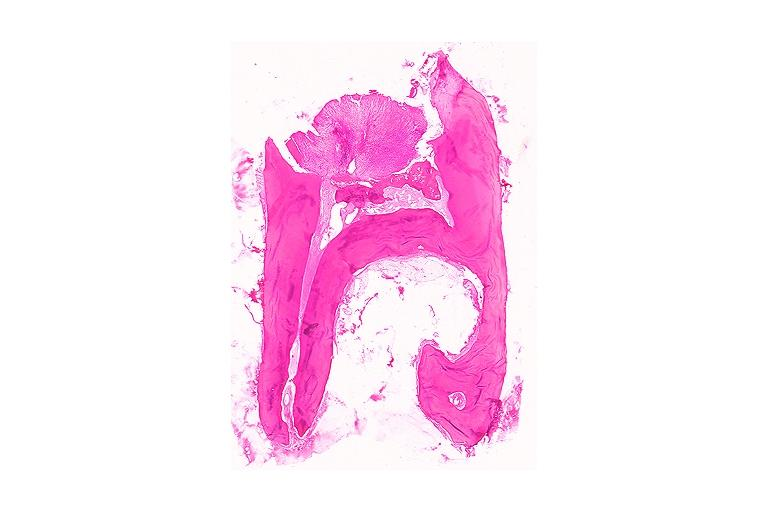s neuronophagia present?
Answer the question using a single word or phrase. No 